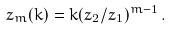Convert formula to latex. <formula><loc_0><loc_0><loc_500><loc_500>z _ { m } ( k ) = k ( z _ { 2 } / z _ { 1 } ) ^ { m - 1 } \, .</formula> 